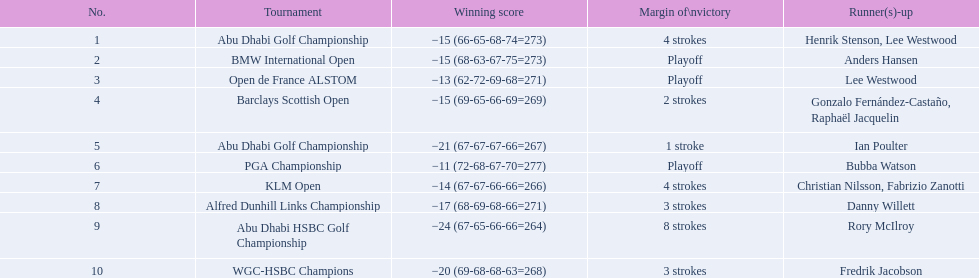How many strokes were in the klm open by martin kaymer? 4 strokes. Parse the full table. {'header': ['No.', 'Tournament', 'Winning score', 'Margin of\\nvictory', 'Runner(s)-up'], 'rows': [['1', 'Abu Dhabi Golf Championship', '−15 (66-65-68-74=273)', '4 strokes', 'Henrik Stenson, Lee Westwood'], ['2', 'BMW International Open', '−15 (68-63-67-75=273)', 'Playoff', 'Anders Hansen'], ['3', 'Open de France ALSTOM', '−13 (62-72-69-68=271)', 'Playoff', 'Lee Westwood'], ['4', 'Barclays Scottish Open', '−15 (69-65-66-69=269)', '2 strokes', 'Gonzalo Fernández-Castaño, Raphaël Jacquelin'], ['5', 'Abu Dhabi Golf Championship', '−21 (67-67-67-66=267)', '1 stroke', 'Ian Poulter'], ['6', 'PGA Championship', '−11 (72-68-67-70=277)', 'Playoff', 'Bubba Watson'], ['7', 'KLM Open', '−14 (67-67-66-66=266)', '4 strokes', 'Christian Nilsson, Fabrizio Zanotti'], ['8', 'Alfred Dunhill Links Championship', '−17 (68-69-68-66=271)', '3 strokes', 'Danny Willett'], ['9', 'Abu Dhabi HSBC Golf Championship', '−24 (67-65-66-66=264)', '8 strokes', 'Rory McIlroy'], ['10', 'WGC-HSBC Champions', '−20 (69-68-68-63=268)', '3 strokes', 'Fredrik Jacobson']]} How many strokes were in the abu dhabi golf championship? 4 strokes. How many more strokes were there in the klm than the barclays open? 2 strokes. 